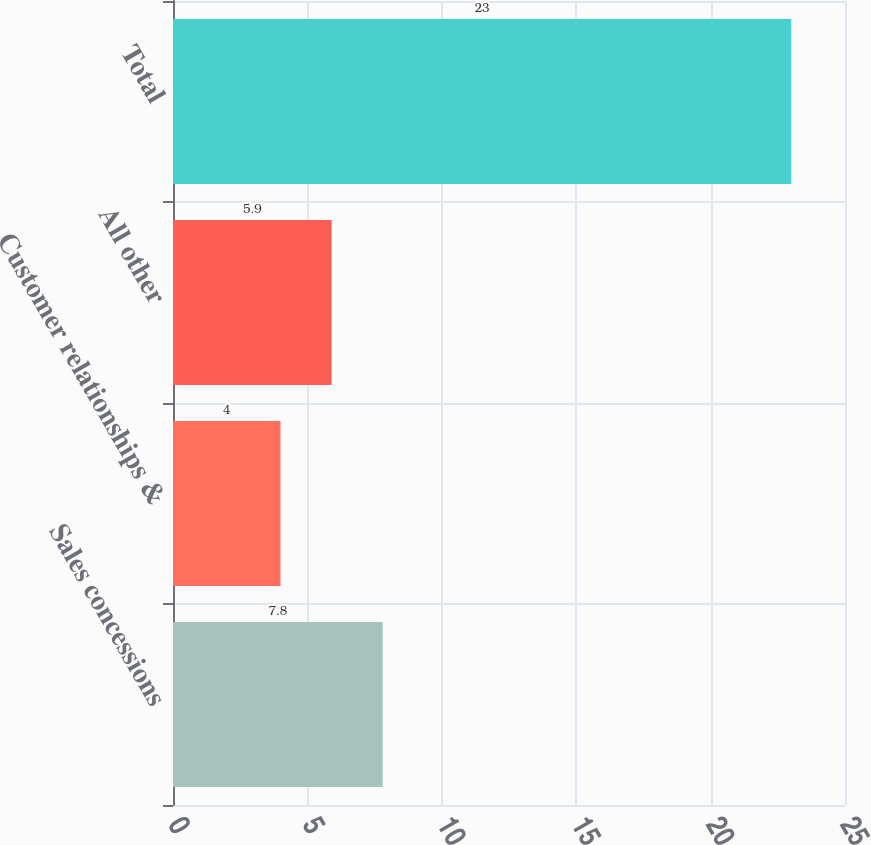<chart> <loc_0><loc_0><loc_500><loc_500><bar_chart><fcel>Sales concessions<fcel>Customer relationships &<fcel>All other<fcel>Total<nl><fcel>7.8<fcel>4<fcel>5.9<fcel>23<nl></chart> 